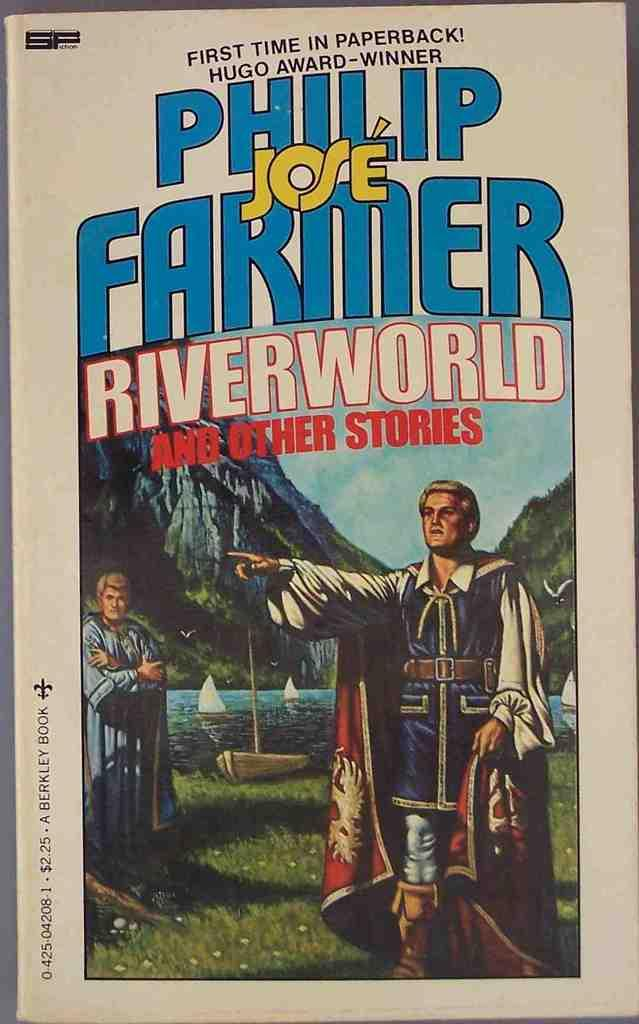<image>
Relay a brief, clear account of the picture shown. A book titled Phillip Jose and Farmer is on a surface. 